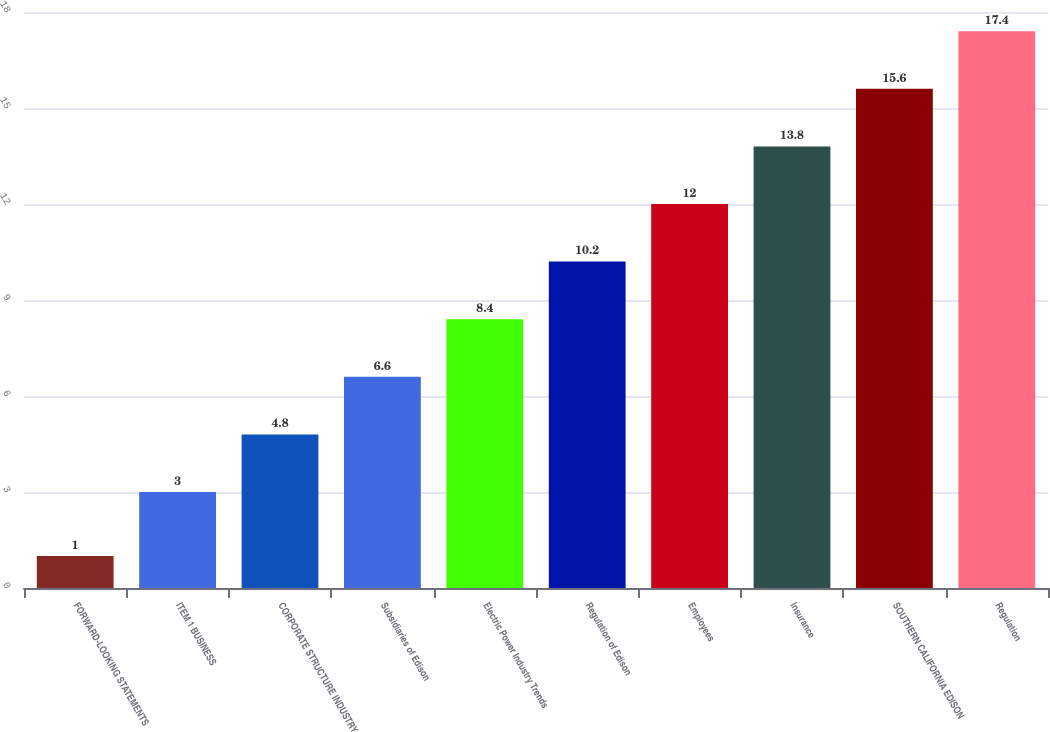Convert chart. <chart><loc_0><loc_0><loc_500><loc_500><bar_chart><fcel>FORWARD-LOOKING STATEMENTS<fcel>ITEM 1 BUSINESS<fcel>CORPORATE STRUCTURE INDUSTRY<fcel>Subsidiaries of Edison<fcel>Electric Power Industry Trends<fcel>Regulation of Edison<fcel>Employees<fcel>Insurance<fcel>SOUTHERN CALIFORNIA EDISON<fcel>Regulation<nl><fcel>1<fcel>3<fcel>4.8<fcel>6.6<fcel>8.4<fcel>10.2<fcel>12<fcel>13.8<fcel>15.6<fcel>17.4<nl></chart> 